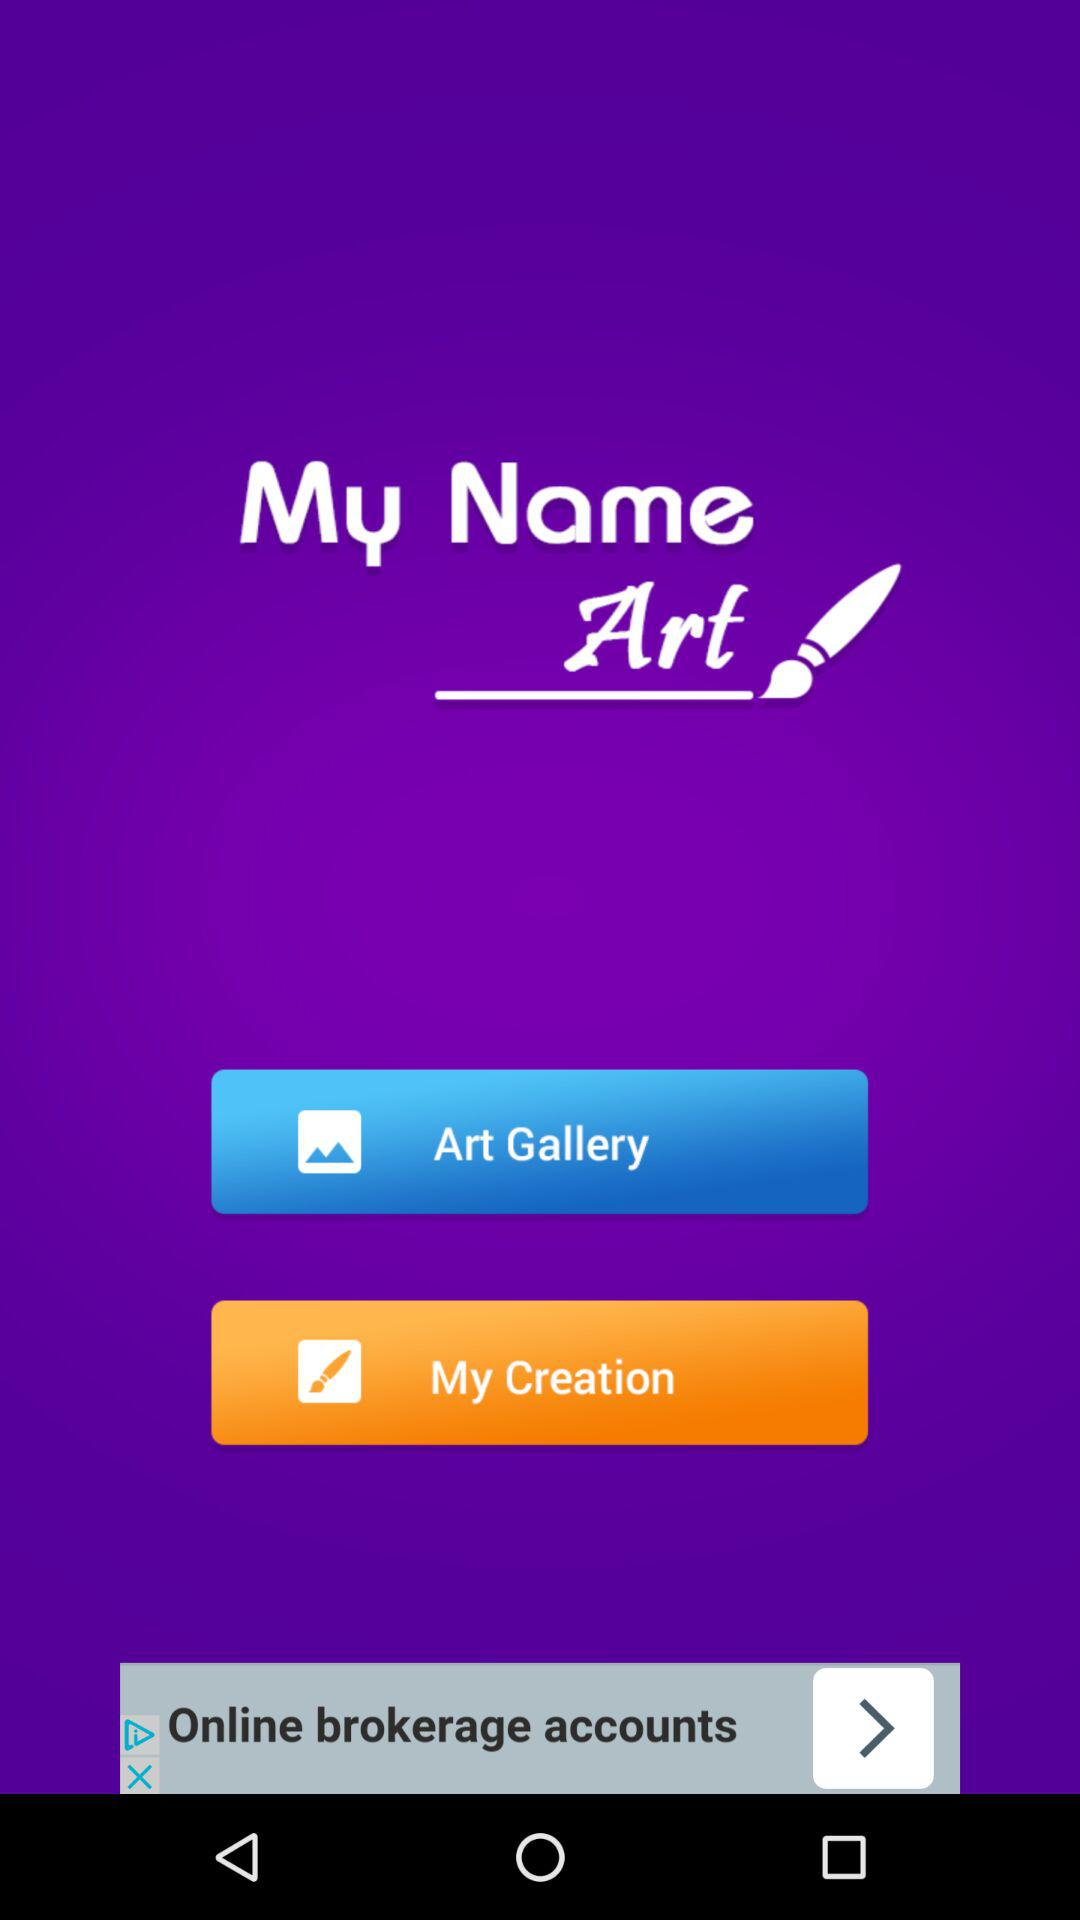What is the name of the application? The name of the application is "My Name Art". 